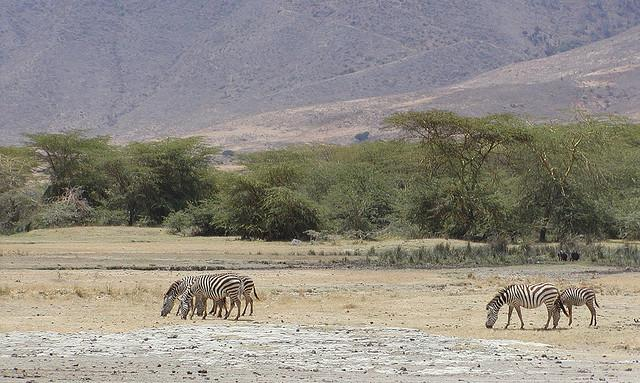What continent do these animals naturally live on? africa 